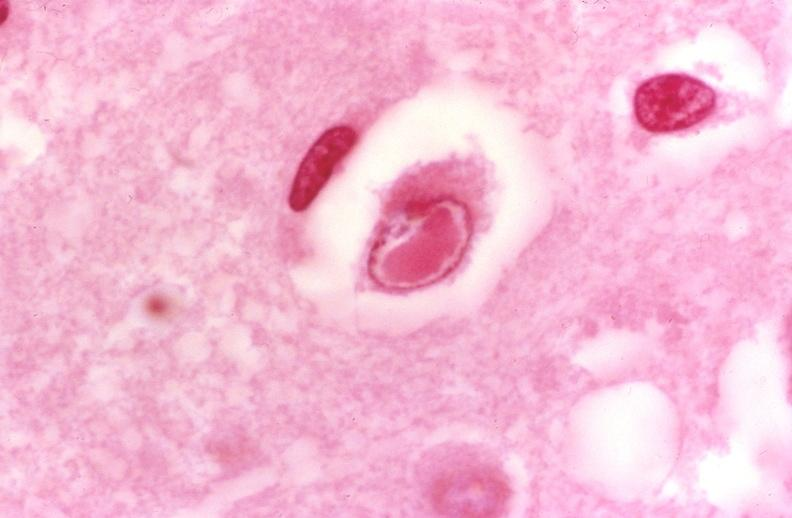what is present?
Answer the question using a single word or phrase. Nervous 